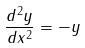<formula> <loc_0><loc_0><loc_500><loc_500>\frac { d ^ { 2 } y } { d x ^ { 2 } } = - y</formula> 